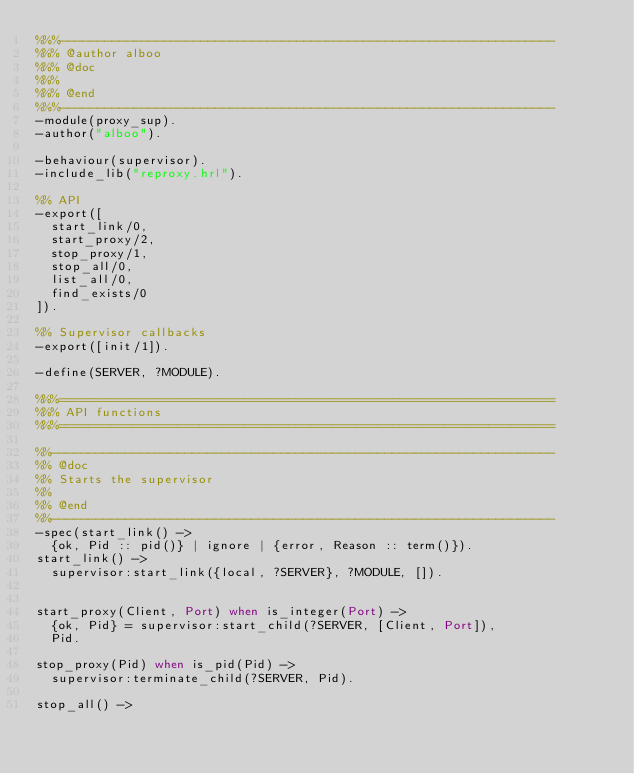Convert code to text. <code><loc_0><loc_0><loc_500><loc_500><_Erlang_>%%%-------------------------------------------------------------------
%%% @author alboo
%%% @doc
%%%
%%% @end
%%%-------------------------------------------------------------------
-module(proxy_sup).
-author("alboo").

-behaviour(supervisor).
-include_lib("reproxy.hrl").

%% API
-export([
  start_link/0,
  start_proxy/2,
  stop_proxy/1,
  stop_all/0,
  list_all/0,
  find_exists/0
]).

%% Supervisor callbacks
-export([init/1]).

-define(SERVER, ?MODULE).

%%%===================================================================
%%% API functions
%%%===================================================================

%%--------------------------------------------------------------------
%% @doc
%% Starts the supervisor
%%
%% @end
%%--------------------------------------------------------------------
-spec(start_link() ->
  {ok, Pid :: pid()} | ignore | {error, Reason :: term()}).
start_link() ->
  supervisor:start_link({local, ?SERVER}, ?MODULE, []).


start_proxy(Client, Port) when is_integer(Port) ->
  {ok, Pid} = supervisor:start_child(?SERVER, [Client, Port]),
  Pid.

stop_proxy(Pid) when is_pid(Pid) ->
  supervisor:terminate_child(?SERVER, Pid).

stop_all() -></code> 